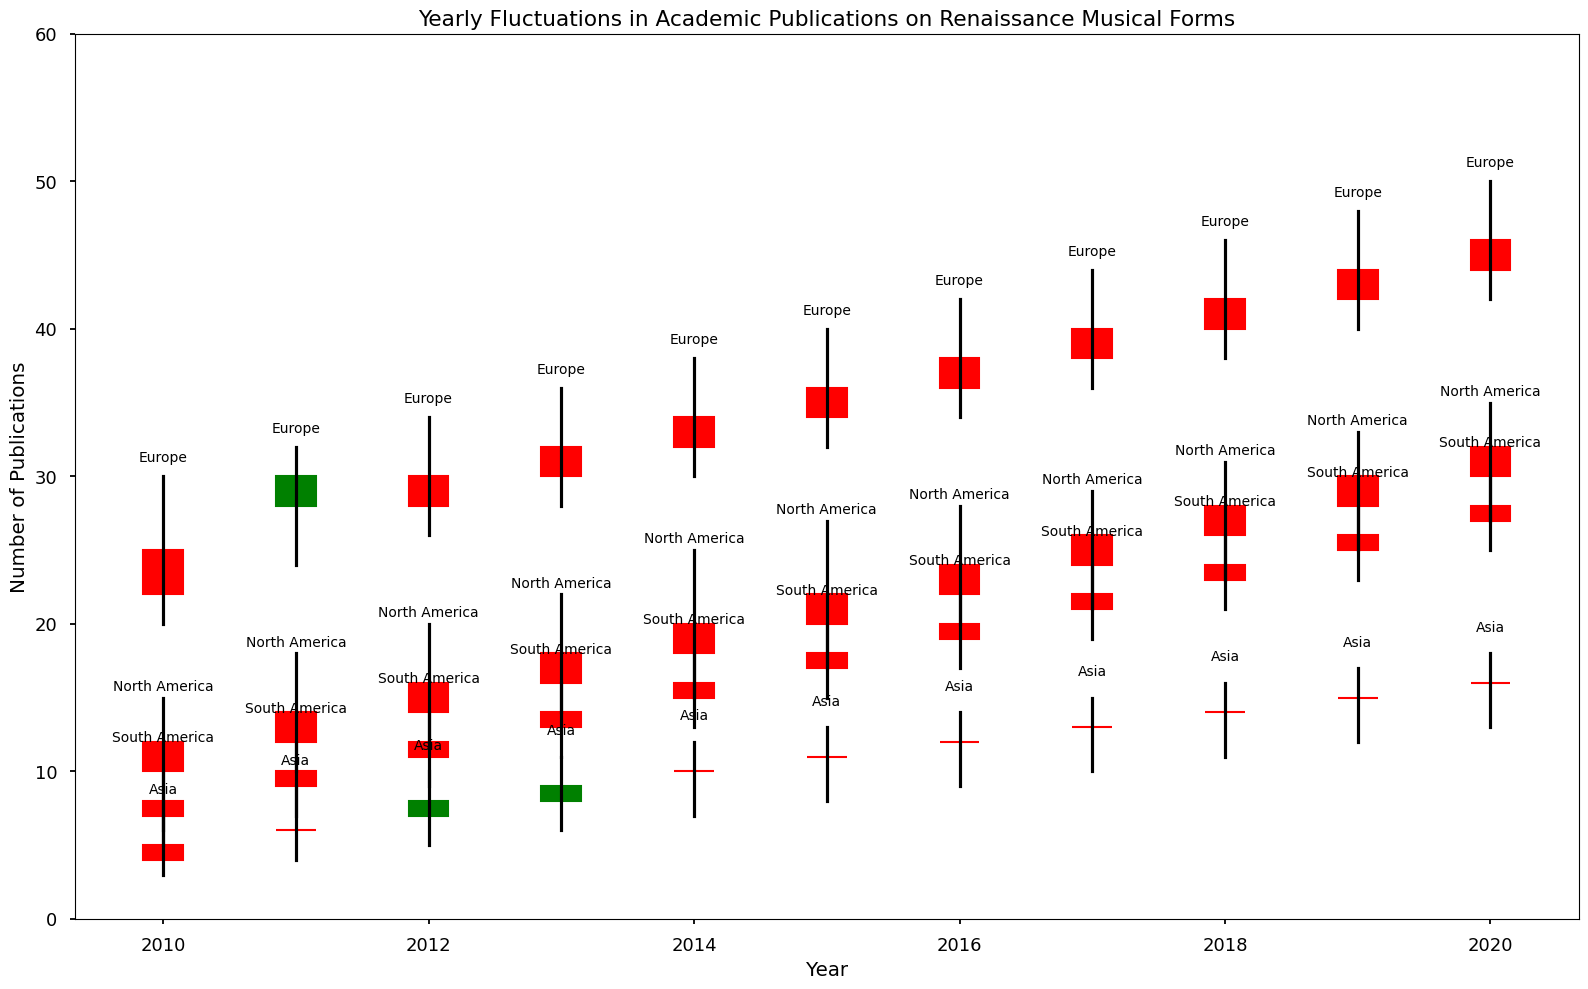Which region had the highest number of publications in 2010? To find the answer, look at the top of the highest candlestick in the year 2010. The region with the highest number of publications in 2010 is displayed at the highest point. The high value for Europe is the highest at 30 publications.
Answer: Europe Which region showed the most significant increase in publications from 2010 to 2020? Calculate the increase in publications for each region by subtracting the opening value in 2010 from the closing value in 2020. For example, Europe had an increase from 25 to 44, which is 19 publications. Compare these increases across all regions. Europe had an increase of 19 publications from 25 to 44.
Answer: Europe By how many publications did Asia's high value change from 2013 to 2016? Locate the high values for Asia in 2013 (11) and compare it to the high value in 2016 (14). Subtract the 2013 value from the 2016 value. 14 - 11 = 3 publications.
Answer: 3 publications Was North America’s lowest number of publications higher in 2014 or 2015? Examine the low values for North America in the years 2014 (15) and 2015 (17). Compare these numbers directly. The low value for 2015 is 17, which is higher than 15 in 2014.
Answer: 2015 What trend can be observed in the number of publications in South America from 2010 to 2020? Inspect the candlestick plots for South America year by year. Analyze the opening and closing values to see if there is a general increase, decrease, or inconsistency in the trend. Starting from 8 in 2010 and rising consistently to 28 by 2020 shows a steady upwards trend.
Answer: Steady increase In which year did Europe have the smallest range of publications? To determine the range, subtract the low value from the high value for each year. Identify the year where the difference between high and low values for Europe is the smallest. For example, in 2012, the high is 34 and the low is 26, so the range is 34 - 26 = 8. The smallest range is in the year 2012 which is 8.
Answer: 2012 Did Asia have a net gain or loss of publications in 2017 compared to 2010? Compare the closing value of 2017 (13) with the opening value of 2010 (5). Subtract the two to find the net change. 13 - 5 = 8, indicating a net gain.
Answer: Net gain Which region had the lowest high value in 2015? Look at the high values for each region in 2015. Identify the smallest value. Asia has the lowest high value at 13 publications in 2015.
Answer: Asia 